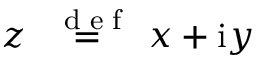Convert formula to latex. <formula><loc_0><loc_0><loc_500><loc_500>z \stackrel { { d e f } } { = } x + i y</formula> 